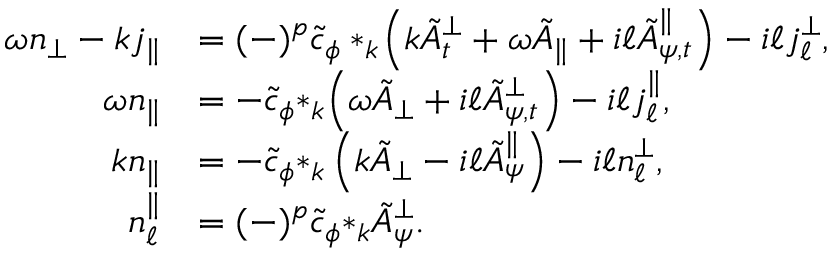<formula> <loc_0><loc_0><loc_500><loc_500>\begin{array} { r l } { \omega { n _ { \perp } } - k { j _ { \| } } } & { = ( - ) ^ { p } \tilde { c } _ { \phi } * _ { k } \, \left ( k { \tilde { A } _ { t } ^ { \perp } } + \omega { \tilde { A } _ { \| } } + i \ell { \tilde { A } _ { \psi , t } ^ { \| } } \right ) - i \ell { j _ { \ell } ^ { \perp } } , } \\ { \omega { n } _ { \| } } & { = - \tilde { c } _ { \phi } { * _ { k } \, \left ( \omega \tilde { A } _ { \perp } + i \ell \tilde { A } _ { \psi , t } ^ { \perp } \right ) } - i \ell j _ { \ell } ^ { \| } , } \\ { k { n _ { \| } } } & { = - \tilde { c } _ { \phi } { * _ { k } \left ( k \tilde { A } _ { \perp } - i \ell \tilde { A } _ { \psi } ^ { \| } \right ) } - i \ell { n _ { \ell } ^ { \perp } } , } \\ { n _ { \ell } ^ { \| } } & { = ( - ) ^ { p } \tilde { c } _ { \phi } { * _ { k } \tilde { A } _ { \psi } ^ { \perp } } . } \end{array}</formula> 